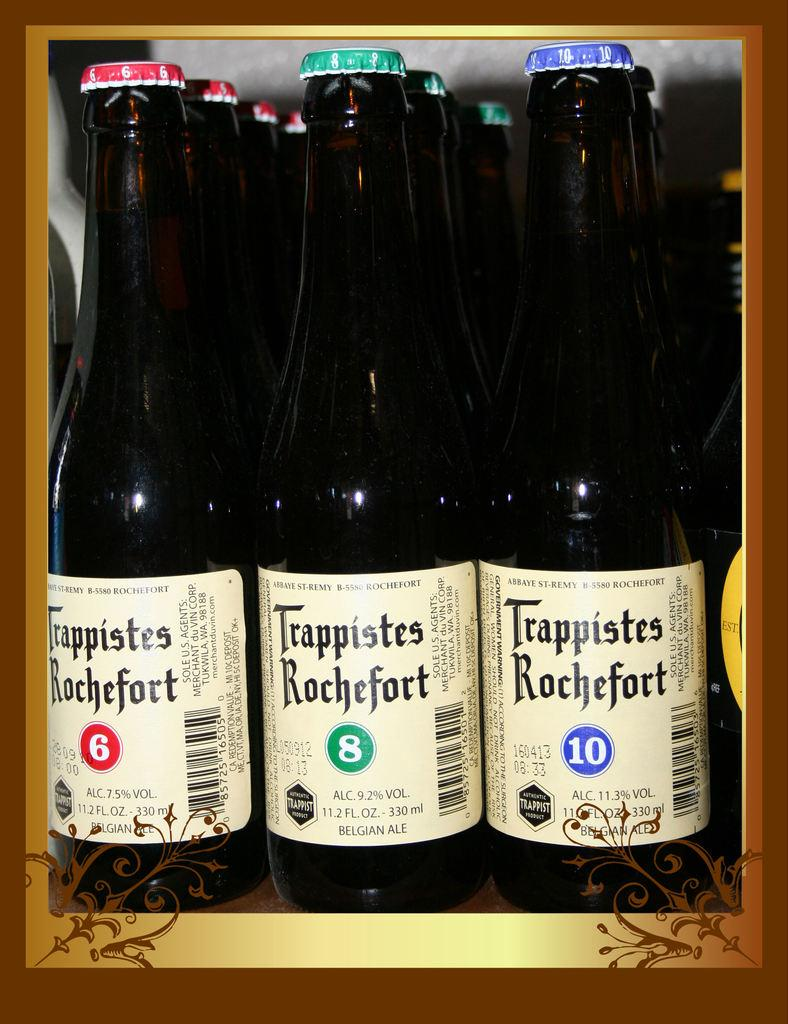<image>
Provide a brief description of the given image. Three bottles of Trappistes Rochefort sit next to each other. 